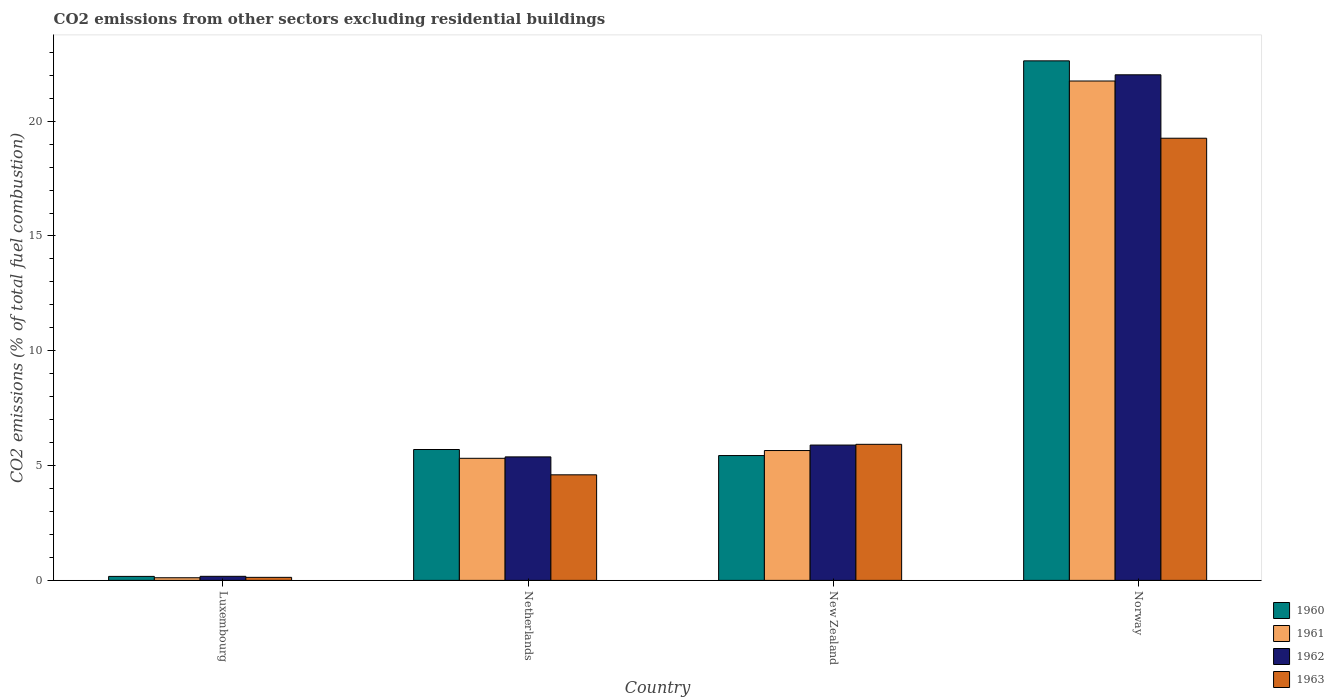Are the number of bars per tick equal to the number of legend labels?
Provide a succinct answer. Yes. Are the number of bars on each tick of the X-axis equal?
Give a very brief answer. Yes. How many bars are there on the 1st tick from the right?
Your response must be concise. 4. What is the total CO2 emitted in 1962 in Norway?
Provide a succinct answer. 22.02. Across all countries, what is the maximum total CO2 emitted in 1963?
Provide a short and direct response. 19.26. Across all countries, what is the minimum total CO2 emitted in 1963?
Offer a terse response. 0.13. In which country was the total CO2 emitted in 1961 maximum?
Provide a short and direct response. Norway. In which country was the total CO2 emitted in 1960 minimum?
Keep it short and to the point. Luxembourg. What is the total total CO2 emitted in 1960 in the graph?
Make the answer very short. 33.94. What is the difference between the total CO2 emitted in 1962 in Luxembourg and that in Netherlands?
Offer a terse response. -5.2. What is the difference between the total CO2 emitted in 1961 in Luxembourg and the total CO2 emitted in 1962 in New Zealand?
Ensure brevity in your answer.  -5.78. What is the average total CO2 emitted in 1962 per country?
Keep it short and to the point. 8.37. What is the difference between the total CO2 emitted of/in 1962 and total CO2 emitted of/in 1961 in Norway?
Your answer should be compact. 0.27. In how many countries, is the total CO2 emitted in 1963 greater than 12?
Make the answer very short. 1. What is the ratio of the total CO2 emitted in 1960 in Netherlands to that in New Zealand?
Provide a succinct answer. 1.05. Is the total CO2 emitted in 1962 in Luxembourg less than that in Norway?
Offer a terse response. Yes. What is the difference between the highest and the second highest total CO2 emitted in 1960?
Offer a very short reply. -0.26. What is the difference between the highest and the lowest total CO2 emitted in 1961?
Make the answer very short. 21.63. In how many countries, is the total CO2 emitted in 1961 greater than the average total CO2 emitted in 1961 taken over all countries?
Keep it short and to the point. 1. Is the sum of the total CO2 emitted in 1962 in Luxembourg and New Zealand greater than the maximum total CO2 emitted in 1963 across all countries?
Your answer should be compact. No. What does the 1st bar from the left in New Zealand represents?
Your answer should be compact. 1960. Is it the case that in every country, the sum of the total CO2 emitted in 1961 and total CO2 emitted in 1962 is greater than the total CO2 emitted in 1960?
Provide a succinct answer. Yes. Are all the bars in the graph horizontal?
Keep it short and to the point. No. How many countries are there in the graph?
Your response must be concise. 4. Are the values on the major ticks of Y-axis written in scientific E-notation?
Offer a very short reply. No. How many legend labels are there?
Provide a succinct answer. 4. What is the title of the graph?
Ensure brevity in your answer.  CO2 emissions from other sectors excluding residential buildings. Does "1978" appear as one of the legend labels in the graph?
Offer a terse response. No. What is the label or title of the X-axis?
Your response must be concise. Country. What is the label or title of the Y-axis?
Your answer should be very brief. CO2 emissions (% of total fuel combustion). What is the CO2 emissions (% of total fuel combustion) of 1960 in Luxembourg?
Offer a terse response. 0.17. What is the CO2 emissions (% of total fuel combustion) in 1961 in Luxembourg?
Provide a succinct answer. 0.11. What is the CO2 emissions (% of total fuel combustion) in 1962 in Luxembourg?
Ensure brevity in your answer.  0.18. What is the CO2 emissions (% of total fuel combustion) of 1963 in Luxembourg?
Provide a short and direct response. 0.13. What is the CO2 emissions (% of total fuel combustion) in 1960 in Netherlands?
Offer a very short reply. 5.7. What is the CO2 emissions (% of total fuel combustion) of 1961 in Netherlands?
Offer a very short reply. 5.32. What is the CO2 emissions (% of total fuel combustion) of 1962 in Netherlands?
Make the answer very short. 5.38. What is the CO2 emissions (% of total fuel combustion) of 1963 in Netherlands?
Your answer should be very brief. 4.6. What is the CO2 emissions (% of total fuel combustion) in 1960 in New Zealand?
Keep it short and to the point. 5.44. What is the CO2 emissions (% of total fuel combustion) of 1961 in New Zealand?
Your response must be concise. 5.66. What is the CO2 emissions (% of total fuel combustion) in 1962 in New Zealand?
Offer a very short reply. 5.89. What is the CO2 emissions (% of total fuel combustion) in 1963 in New Zealand?
Give a very brief answer. 5.93. What is the CO2 emissions (% of total fuel combustion) of 1960 in Norway?
Provide a short and direct response. 22.63. What is the CO2 emissions (% of total fuel combustion) in 1961 in Norway?
Give a very brief answer. 21.75. What is the CO2 emissions (% of total fuel combustion) of 1962 in Norway?
Provide a succinct answer. 22.02. What is the CO2 emissions (% of total fuel combustion) of 1963 in Norway?
Give a very brief answer. 19.26. Across all countries, what is the maximum CO2 emissions (% of total fuel combustion) of 1960?
Your answer should be compact. 22.63. Across all countries, what is the maximum CO2 emissions (% of total fuel combustion) of 1961?
Ensure brevity in your answer.  21.75. Across all countries, what is the maximum CO2 emissions (% of total fuel combustion) in 1962?
Offer a terse response. 22.02. Across all countries, what is the maximum CO2 emissions (% of total fuel combustion) of 1963?
Give a very brief answer. 19.26. Across all countries, what is the minimum CO2 emissions (% of total fuel combustion) of 1960?
Your response must be concise. 0.17. Across all countries, what is the minimum CO2 emissions (% of total fuel combustion) in 1961?
Provide a succinct answer. 0.11. Across all countries, what is the minimum CO2 emissions (% of total fuel combustion) of 1962?
Keep it short and to the point. 0.18. Across all countries, what is the minimum CO2 emissions (% of total fuel combustion) of 1963?
Make the answer very short. 0.13. What is the total CO2 emissions (% of total fuel combustion) in 1960 in the graph?
Make the answer very short. 33.94. What is the total CO2 emissions (% of total fuel combustion) of 1961 in the graph?
Your answer should be compact. 32.84. What is the total CO2 emissions (% of total fuel combustion) in 1962 in the graph?
Keep it short and to the point. 33.47. What is the total CO2 emissions (% of total fuel combustion) of 1963 in the graph?
Your response must be concise. 29.91. What is the difference between the CO2 emissions (% of total fuel combustion) in 1960 in Luxembourg and that in Netherlands?
Your response must be concise. -5.53. What is the difference between the CO2 emissions (% of total fuel combustion) in 1961 in Luxembourg and that in Netherlands?
Your answer should be very brief. -5.2. What is the difference between the CO2 emissions (% of total fuel combustion) of 1962 in Luxembourg and that in Netherlands?
Give a very brief answer. -5.2. What is the difference between the CO2 emissions (% of total fuel combustion) of 1963 in Luxembourg and that in Netherlands?
Ensure brevity in your answer.  -4.47. What is the difference between the CO2 emissions (% of total fuel combustion) in 1960 in Luxembourg and that in New Zealand?
Provide a short and direct response. -5.26. What is the difference between the CO2 emissions (% of total fuel combustion) in 1961 in Luxembourg and that in New Zealand?
Give a very brief answer. -5.54. What is the difference between the CO2 emissions (% of total fuel combustion) of 1962 in Luxembourg and that in New Zealand?
Provide a short and direct response. -5.72. What is the difference between the CO2 emissions (% of total fuel combustion) in 1963 in Luxembourg and that in New Zealand?
Offer a terse response. -5.79. What is the difference between the CO2 emissions (% of total fuel combustion) of 1960 in Luxembourg and that in Norway?
Give a very brief answer. -22.45. What is the difference between the CO2 emissions (% of total fuel combustion) of 1961 in Luxembourg and that in Norway?
Your answer should be very brief. -21.63. What is the difference between the CO2 emissions (% of total fuel combustion) in 1962 in Luxembourg and that in Norway?
Provide a short and direct response. -21.84. What is the difference between the CO2 emissions (% of total fuel combustion) in 1963 in Luxembourg and that in Norway?
Make the answer very short. -19.12. What is the difference between the CO2 emissions (% of total fuel combustion) in 1960 in Netherlands and that in New Zealand?
Give a very brief answer. 0.26. What is the difference between the CO2 emissions (% of total fuel combustion) in 1961 in Netherlands and that in New Zealand?
Provide a short and direct response. -0.34. What is the difference between the CO2 emissions (% of total fuel combustion) in 1962 in Netherlands and that in New Zealand?
Offer a very short reply. -0.52. What is the difference between the CO2 emissions (% of total fuel combustion) of 1963 in Netherlands and that in New Zealand?
Your answer should be compact. -1.33. What is the difference between the CO2 emissions (% of total fuel combustion) of 1960 in Netherlands and that in Norway?
Keep it short and to the point. -16.93. What is the difference between the CO2 emissions (% of total fuel combustion) in 1961 in Netherlands and that in Norway?
Give a very brief answer. -16.43. What is the difference between the CO2 emissions (% of total fuel combustion) of 1962 in Netherlands and that in Norway?
Offer a very short reply. -16.64. What is the difference between the CO2 emissions (% of total fuel combustion) of 1963 in Netherlands and that in Norway?
Provide a short and direct response. -14.66. What is the difference between the CO2 emissions (% of total fuel combustion) of 1960 in New Zealand and that in Norway?
Provide a short and direct response. -17.19. What is the difference between the CO2 emissions (% of total fuel combustion) of 1961 in New Zealand and that in Norway?
Provide a short and direct response. -16.09. What is the difference between the CO2 emissions (% of total fuel combustion) of 1962 in New Zealand and that in Norway?
Make the answer very short. -16.13. What is the difference between the CO2 emissions (% of total fuel combustion) of 1963 in New Zealand and that in Norway?
Provide a short and direct response. -13.33. What is the difference between the CO2 emissions (% of total fuel combustion) in 1960 in Luxembourg and the CO2 emissions (% of total fuel combustion) in 1961 in Netherlands?
Offer a very short reply. -5.14. What is the difference between the CO2 emissions (% of total fuel combustion) in 1960 in Luxembourg and the CO2 emissions (% of total fuel combustion) in 1962 in Netherlands?
Your answer should be very brief. -5.2. What is the difference between the CO2 emissions (% of total fuel combustion) of 1960 in Luxembourg and the CO2 emissions (% of total fuel combustion) of 1963 in Netherlands?
Make the answer very short. -4.42. What is the difference between the CO2 emissions (% of total fuel combustion) in 1961 in Luxembourg and the CO2 emissions (% of total fuel combustion) in 1962 in Netherlands?
Your answer should be very brief. -5.26. What is the difference between the CO2 emissions (% of total fuel combustion) of 1961 in Luxembourg and the CO2 emissions (% of total fuel combustion) of 1963 in Netherlands?
Offer a terse response. -4.48. What is the difference between the CO2 emissions (% of total fuel combustion) in 1962 in Luxembourg and the CO2 emissions (% of total fuel combustion) in 1963 in Netherlands?
Keep it short and to the point. -4.42. What is the difference between the CO2 emissions (% of total fuel combustion) in 1960 in Luxembourg and the CO2 emissions (% of total fuel combustion) in 1961 in New Zealand?
Your response must be concise. -5.48. What is the difference between the CO2 emissions (% of total fuel combustion) in 1960 in Luxembourg and the CO2 emissions (% of total fuel combustion) in 1962 in New Zealand?
Offer a terse response. -5.72. What is the difference between the CO2 emissions (% of total fuel combustion) in 1960 in Luxembourg and the CO2 emissions (% of total fuel combustion) in 1963 in New Zealand?
Make the answer very short. -5.75. What is the difference between the CO2 emissions (% of total fuel combustion) in 1961 in Luxembourg and the CO2 emissions (% of total fuel combustion) in 1962 in New Zealand?
Your answer should be very brief. -5.78. What is the difference between the CO2 emissions (% of total fuel combustion) of 1961 in Luxembourg and the CO2 emissions (% of total fuel combustion) of 1963 in New Zealand?
Provide a short and direct response. -5.81. What is the difference between the CO2 emissions (% of total fuel combustion) of 1962 in Luxembourg and the CO2 emissions (% of total fuel combustion) of 1963 in New Zealand?
Provide a succinct answer. -5.75. What is the difference between the CO2 emissions (% of total fuel combustion) of 1960 in Luxembourg and the CO2 emissions (% of total fuel combustion) of 1961 in Norway?
Offer a very short reply. -21.58. What is the difference between the CO2 emissions (% of total fuel combustion) in 1960 in Luxembourg and the CO2 emissions (% of total fuel combustion) in 1962 in Norway?
Your response must be concise. -21.85. What is the difference between the CO2 emissions (% of total fuel combustion) of 1960 in Luxembourg and the CO2 emissions (% of total fuel combustion) of 1963 in Norway?
Keep it short and to the point. -19.08. What is the difference between the CO2 emissions (% of total fuel combustion) in 1961 in Luxembourg and the CO2 emissions (% of total fuel combustion) in 1962 in Norway?
Keep it short and to the point. -21.91. What is the difference between the CO2 emissions (% of total fuel combustion) in 1961 in Luxembourg and the CO2 emissions (% of total fuel combustion) in 1963 in Norway?
Offer a very short reply. -19.14. What is the difference between the CO2 emissions (% of total fuel combustion) in 1962 in Luxembourg and the CO2 emissions (% of total fuel combustion) in 1963 in Norway?
Make the answer very short. -19.08. What is the difference between the CO2 emissions (% of total fuel combustion) in 1960 in Netherlands and the CO2 emissions (% of total fuel combustion) in 1961 in New Zealand?
Offer a terse response. 0.05. What is the difference between the CO2 emissions (% of total fuel combustion) in 1960 in Netherlands and the CO2 emissions (% of total fuel combustion) in 1962 in New Zealand?
Your answer should be compact. -0.19. What is the difference between the CO2 emissions (% of total fuel combustion) of 1960 in Netherlands and the CO2 emissions (% of total fuel combustion) of 1963 in New Zealand?
Your answer should be compact. -0.23. What is the difference between the CO2 emissions (% of total fuel combustion) in 1961 in Netherlands and the CO2 emissions (% of total fuel combustion) in 1962 in New Zealand?
Give a very brief answer. -0.58. What is the difference between the CO2 emissions (% of total fuel combustion) in 1961 in Netherlands and the CO2 emissions (% of total fuel combustion) in 1963 in New Zealand?
Your answer should be compact. -0.61. What is the difference between the CO2 emissions (% of total fuel combustion) in 1962 in Netherlands and the CO2 emissions (% of total fuel combustion) in 1963 in New Zealand?
Ensure brevity in your answer.  -0.55. What is the difference between the CO2 emissions (% of total fuel combustion) in 1960 in Netherlands and the CO2 emissions (% of total fuel combustion) in 1961 in Norway?
Provide a succinct answer. -16.05. What is the difference between the CO2 emissions (% of total fuel combustion) in 1960 in Netherlands and the CO2 emissions (% of total fuel combustion) in 1962 in Norway?
Offer a terse response. -16.32. What is the difference between the CO2 emissions (% of total fuel combustion) of 1960 in Netherlands and the CO2 emissions (% of total fuel combustion) of 1963 in Norway?
Offer a terse response. -13.56. What is the difference between the CO2 emissions (% of total fuel combustion) of 1961 in Netherlands and the CO2 emissions (% of total fuel combustion) of 1962 in Norway?
Offer a terse response. -16.7. What is the difference between the CO2 emissions (% of total fuel combustion) in 1961 in Netherlands and the CO2 emissions (% of total fuel combustion) in 1963 in Norway?
Give a very brief answer. -13.94. What is the difference between the CO2 emissions (% of total fuel combustion) of 1962 in Netherlands and the CO2 emissions (% of total fuel combustion) of 1963 in Norway?
Your answer should be compact. -13.88. What is the difference between the CO2 emissions (% of total fuel combustion) of 1960 in New Zealand and the CO2 emissions (% of total fuel combustion) of 1961 in Norway?
Offer a very short reply. -16.31. What is the difference between the CO2 emissions (% of total fuel combustion) in 1960 in New Zealand and the CO2 emissions (% of total fuel combustion) in 1962 in Norway?
Provide a succinct answer. -16.58. What is the difference between the CO2 emissions (% of total fuel combustion) in 1960 in New Zealand and the CO2 emissions (% of total fuel combustion) in 1963 in Norway?
Provide a short and direct response. -13.82. What is the difference between the CO2 emissions (% of total fuel combustion) in 1961 in New Zealand and the CO2 emissions (% of total fuel combustion) in 1962 in Norway?
Your answer should be compact. -16.36. What is the difference between the CO2 emissions (% of total fuel combustion) in 1961 in New Zealand and the CO2 emissions (% of total fuel combustion) in 1963 in Norway?
Offer a terse response. -13.6. What is the difference between the CO2 emissions (% of total fuel combustion) of 1962 in New Zealand and the CO2 emissions (% of total fuel combustion) of 1963 in Norway?
Your response must be concise. -13.36. What is the average CO2 emissions (% of total fuel combustion) in 1960 per country?
Offer a terse response. 8.48. What is the average CO2 emissions (% of total fuel combustion) of 1961 per country?
Give a very brief answer. 8.21. What is the average CO2 emissions (% of total fuel combustion) in 1962 per country?
Your answer should be compact. 8.37. What is the average CO2 emissions (% of total fuel combustion) in 1963 per country?
Offer a terse response. 7.48. What is the difference between the CO2 emissions (% of total fuel combustion) in 1960 and CO2 emissions (% of total fuel combustion) in 1961 in Luxembourg?
Your answer should be compact. 0.06. What is the difference between the CO2 emissions (% of total fuel combustion) of 1960 and CO2 emissions (% of total fuel combustion) of 1962 in Luxembourg?
Ensure brevity in your answer.  -0. What is the difference between the CO2 emissions (% of total fuel combustion) of 1960 and CO2 emissions (% of total fuel combustion) of 1963 in Luxembourg?
Give a very brief answer. 0.04. What is the difference between the CO2 emissions (% of total fuel combustion) in 1961 and CO2 emissions (% of total fuel combustion) in 1962 in Luxembourg?
Provide a short and direct response. -0.06. What is the difference between the CO2 emissions (% of total fuel combustion) of 1961 and CO2 emissions (% of total fuel combustion) of 1963 in Luxembourg?
Your answer should be compact. -0.02. What is the difference between the CO2 emissions (% of total fuel combustion) of 1962 and CO2 emissions (% of total fuel combustion) of 1963 in Luxembourg?
Provide a short and direct response. 0.04. What is the difference between the CO2 emissions (% of total fuel combustion) of 1960 and CO2 emissions (% of total fuel combustion) of 1961 in Netherlands?
Your response must be concise. 0.38. What is the difference between the CO2 emissions (% of total fuel combustion) in 1960 and CO2 emissions (% of total fuel combustion) in 1962 in Netherlands?
Give a very brief answer. 0.32. What is the difference between the CO2 emissions (% of total fuel combustion) of 1960 and CO2 emissions (% of total fuel combustion) of 1963 in Netherlands?
Keep it short and to the point. 1.1. What is the difference between the CO2 emissions (% of total fuel combustion) of 1961 and CO2 emissions (% of total fuel combustion) of 1962 in Netherlands?
Your response must be concise. -0.06. What is the difference between the CO2 emissions (% of total fuel combustion) of 1961 and CO2 emissions (% of total fuel combustion) of 1963 in Netherlands?
Offer a terse response. 0.72. What is the difference between the CO2 emissions (% of total fuel combustion) in 1962 and CO2 emissions (% of total fuel combustion) in 1963 in Netherlands?
Your answer should be compact. 0.78. What is the difference between the CO2 emissions (% of total fuel combustion) in 1960 and CO2 emissions (% of total fuel combustion) in 1961 in New Zealand?
Your response must be concise. -0.22. What is the difference between the CO2 emissions (% of total fuel combustion) in 1960 and CO2 emissions (% of total fuel combustion) in 1962 in New Zealand?
Make the answer very short. -0.46. What is the difference between the CO2 emissions (% of total fuel combustion) of 1960 and CO2 emissions (% of total fuel combustion) of 1963 in New Zealand?
Offer a very short reply. -0.49. What is the difference between the CO2 emissions (% of total fuel combustion) in 1961 and CO2 emissions (% of total fuel combustion) in 1962 in New Zealand?
Give a very brief answer. -0.24. What is the difference between the CO2 emissions (% of total fuel combustion) of 1961 and CO2 emissions (% of total fuel combustion) of 1963 in New Zealand?
Offer a very short reply. -0.27. What is the difference between the CO2 emissions (% of total fuel combustion) of 1962 and CO2 emissions (% of total fuel combustion) of 1963 in New Zealand?
Ensure brevity in your answer.  -0.03. What is the difference between the CO2 emissions (% of total fuel combustion) in 1960 and CO2 emissions (% of total fuel combustion) in 1961 in Norway?
Make the answer very short. 0.88. What is the difference between the CO2 emissions (% of total fuel combustion) of 1960 and CO2 emissions (% of total fuel combustion) of 1962 in Norway?
Your answer should be compact. 0.61. What is the difference between the CO2 emissions (% of total fuel combustion) in 1960 and CO2 emissions (% of total fuel combustion) in 1963 in Norway?
Make the answer very short. 3.37. What is the difference between the CO2 emissions (% of total fuel combustion) in 1961 and CO2 emissions (% of total fuel combustion) in 1962 in Norway?
Offer a very short reply. -0.27. What is the difference between the CO2 emissions (% of total fuel combustion) of 1961 and CO2 emissions (% of total fuel combustion) of 1963 in Norway?
Ensure brevity in your answer.  2.49. What is the difference between the CO2 emissions (% of total fuel combustion) of 1962 and CO2 emissions (% of total fuel combustion) of 1963 in Norway?
Keep it short and to the point. 2.76. What is the ratio of the CO2 emissions (% of total fuel combustion) of 1960 in Luxembourg to that in Netherlands?
Provide a succinct answer. 0.03. What is the ratio of the CO2 emissions (% of total fuel combustion) in 1961 in Luxembourg to that in Netherlands?
Ensure brevity in your answer.  0.02. What is the ratio of the CO2 emissions (% of total fuel combustion) of 1962 in Luxembourg to that in Netherlands?
Provide a short and direct response. 0.03. What is the ratio of the CO2 emissions (% of total fuel combustion) of 1963 in Luxembourg to that in Netherlands?
Your answer should be compact. 0.03. What is the ratio of the CO2 emissions (% of total fuel combustion) in 1960 in Luxembourg to that in New Zealand?
Offer a terse response. 0.03. What is the ratio of the CO2 emissions (% of total fuel combustion) in 1961 in Luxembourg to that in New Zealand?
Your response must be concise. 0.02. What is the ratio of the CO2 emissions (% of total fuel combustion) of 1963 in Luxembourg to that in New Zealand?
Keep it short and to the point. 0.02. What is the ratio of the CO2 emissions (% of total fuel combustion) of 1960 in Luxembourg to that in Norway?
Offer a very short reply. 0.01. What is the ratio of the CO2 emissions (% of total fuel combustion) of 1961 in Luxembourg to that in Norway?
Offer a very short reply. 0.01. What is the ratio of the CO2 emissions (% of total fuel combustion) in 1962 in Luxembourg to that in Norway?
Ensure brevity in your answer.  0.01. What is the ratio of the CO2 emissions (% of total fuel combustion) of 1963 in Luxembourg to that in Norway?
Provide a short and direct response. 0.01. What is the ratio of the CO2 emissions (% of total fuel combustion) in 1960 in Netherlands to that in New Zealand?
Provide a short and direct response. 1.05. What is the ratio of the CO2 emissions (% of total fuel combustion) in 1961 in Netherlands to that in New Zealand?
Your response must be concise. 0.94. What is the ratio of the CO2 emissions (% of total fuel combustion) in 1962 in Netherlands to that in New Zealand?
Keep it short and to the point. 0.91. What is the ratio of the CO2 emissions (% of total fuel combustion) in 1963 in Netherlands to that in New Zealand?
Give a very brief answer. 0.78. What is the ratio of the CO2 emissions (% of total fuel combustion) of 1960 in Netherlands to that in Norway?
Ensure brevity in your answer.  0.25. What is the ratio of the CO2 emissions (% of total fuel combustion) of 1961 in Netherlands to that in Norway?
Provide a short and direct response. 0.24. What is the ratio of the CO2 emissions (% of total fuel combustion) in 1962 in Netherlands to that in Norway?
Give a very brief answer. 0.24. What is the ratio of the CO2 emissions (% of total fuel combustion) in 1963 in Netherlands to that in Norway?
Provide a short and direct response. 0.24. What is the ratio of the CO2 emissions (% of total fuel combustion) in 1960 in New Zealand to that in Norway?
Your answer should be very brief. 0.24. What is the ratio of the CO2 emissions (% of total fuel combustion) in 1961 in New Zealand to that in Norway?
Provide a short and direct response. 0.26. What is the ratio of the CO2 emissions (% of total fuel combustion) of 1962 in New Zealand to that in Norway?
Your answer should be very brief. 0.27. What is the ratio of the CO2 emissions (% of total fuel combustion) in 1963 in New Zealand to that in Norway?
Provide a succinct answer. 0.31. What is the difference between the highest and the second highest CO2 emissions (% of total fuel combustion) in 1960?
Provide a short and direct response. 16.93. What is the difference between the highest and the second highest CO2 emissions (% of total fuel combustion) in 1961?
Provide a succinct answer. 16.09. What is the difference between the highest and the second highest CO2 emissions (% of total fuel combustion) of 1962?
Your response must be concise. 16.13. What is the difference between the highest and the second highest CO2 emissions (% of total fuel combustion) in 1963?
Give a very brief answer. 13.33. What is the difference between the highest and the lowest CO2 emissions (% of total fuel combustion) of 1960?
Keep it short and to the point. 22.45. What is the difference between the highest and the lowest CO2 emissions (% of total fuel combustion) in 1961?
Your answer should be compact. 21.63. What is the difference between the highest and the lowest CO2 emissions (% of total fuel combustion) of 1962?
Your response must be concise. 21.84. What is the difference between the highest and the lowest CO2 emissions (% of total fuel combustion) of 1963?
Keep it short and to the point. 19.12. 